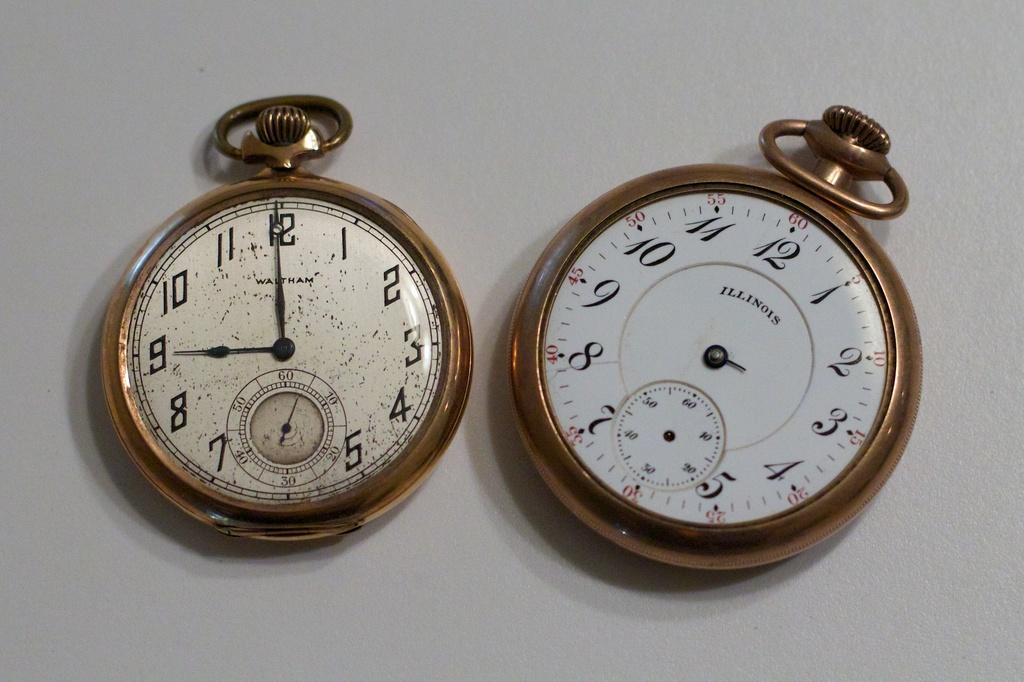<image>
Give a short and clear explanation of the subsequent image. Two pocket watches side by side on of which says Illinois. 